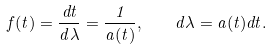<formula> <loc_0><loc_0><loc_500><loc_500>f ( t ) = \frac { d t } { d \lambda } = \frac { 1 } { a ( t ) } , \quad d \lambda = a ( t ) d t .</formula> 